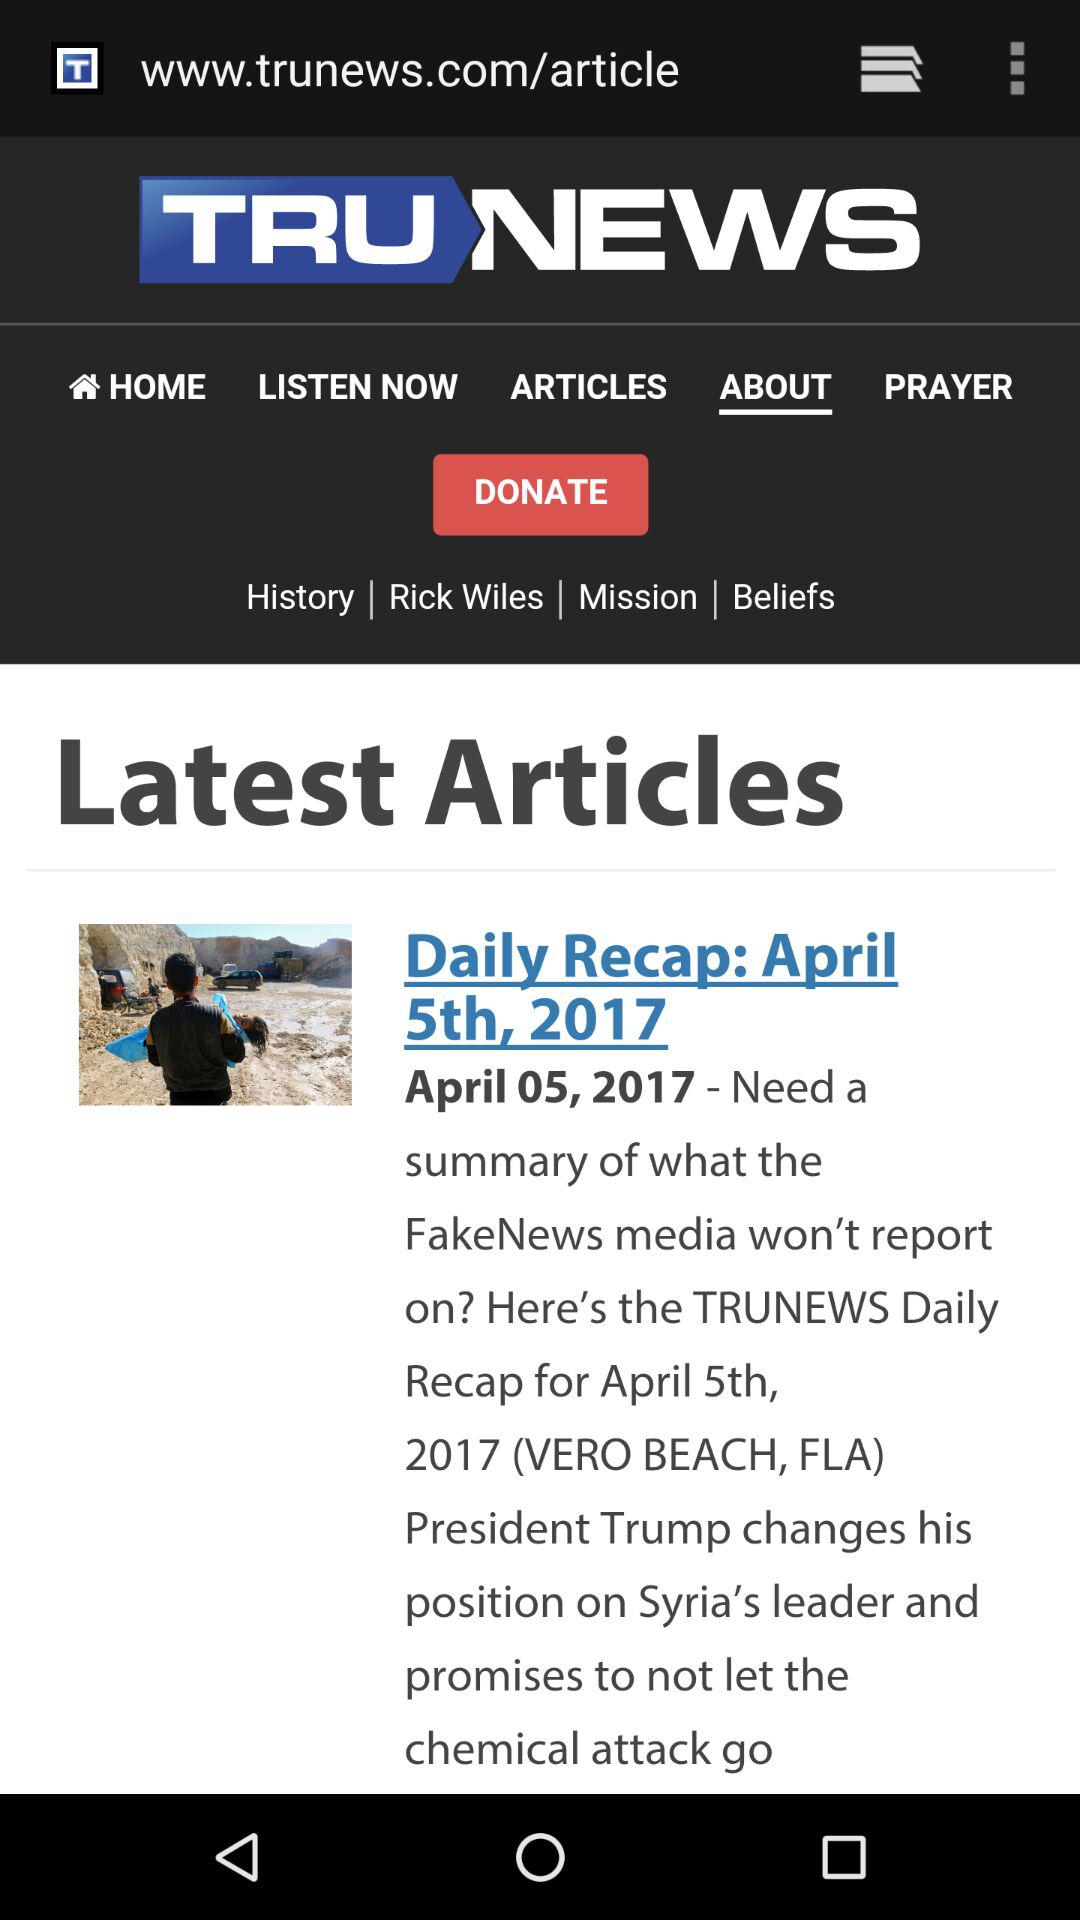Which option is selected in "TRUNEWS"? The selected option is "ABOUT". 